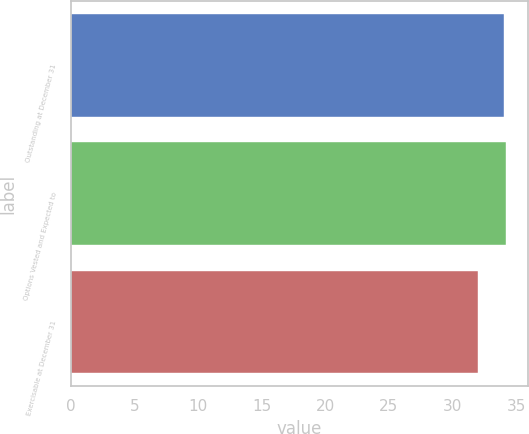<chart> <loc_0><loc_0><loc_500><loc_500><bar_chart><fcel>Outstanding at December 31<fcel>Options Vested and Expected to<fcel>Exercisable at December 31<nl><fcel>34<fcel>34.2<fcel>32<nl></chart> 